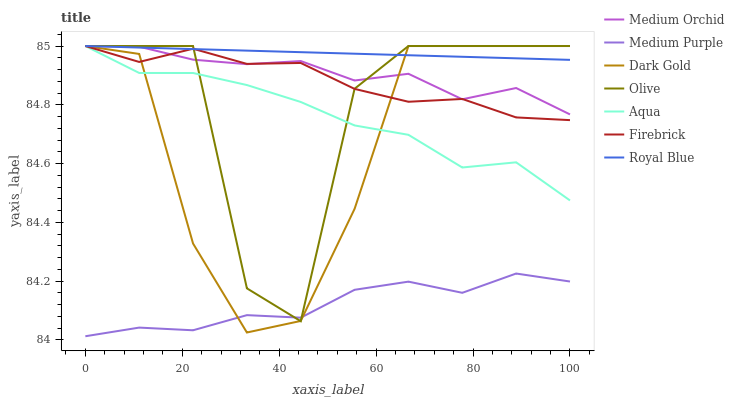Does Medium Purple have the minimum area under the curve?
Answer yes or no. Yes. Does Royal Blue have the maximum area under the curve?
Answer yes or no. Yes. Does Firebrick have the minimum area under the curve?
Answer yes or no. No. Does Firebrick have the maximum area under the curve?
Answer yes or no. No. Is Royal Blue the smoothest?
Answer yes or no. Yes. Is Olive the roughest?
Answer yes or no. Yes. Is Firebrick the smoothest?
Answer yes or no. No. Is Firebrick the roughest?
Answer yes or no. No. Does Medium Purple have the lowest value?
Answer yes or no. Yes. Does Firebrick have the lowest value?
Answer yes or no. No. Does Olive have the highest value?
Answer yes or no. Yes. Does Medium Purple have the highest value?
Answer yes or no. No. Is Medium Purple less than Royal Blue?
Answer yes or no. Yes. Is Medium Orchid greater than Medium Purple?
Answer yes or no. Yes. Does Medium Orchid intersect Firebrick?
Answer yes or no. Yes. Is Medium Orchid less than Firebrick?
Answer yes or no. No. Is Medium Orchid greater than Firebrick?
Answer yes or no. No. Does Medium Purple intersect Royal Blue?
Answer yes or no. No. 